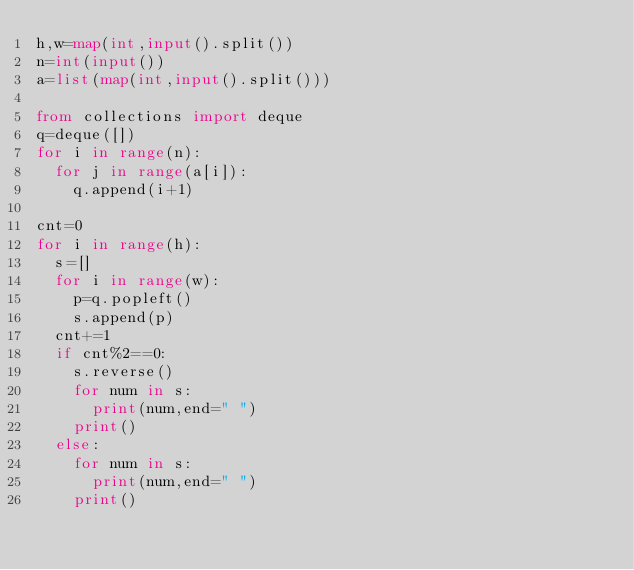<code> <loc_0><loc_0><loc_500><loc_500><_Python_>h,w=map(int,input().split())
n=int(input())
a=list(map(int,input().split()))

from collections import deque
q=deque([])
for i in range(n):
  for j in range(a[i]):
    q.append(i+1)

cnt=0
for i in range(h):
  s=[]
  for i in range(w):
    p=q.popleft()
    s.append(p)
  cnt+=1
  if cnt%2==0:
    s.reverse()
    for num in s:
      print(num,end=" ")
    print()
  else:
    for num in s:
      print(num,end=" ")
    print()
    
</code> 